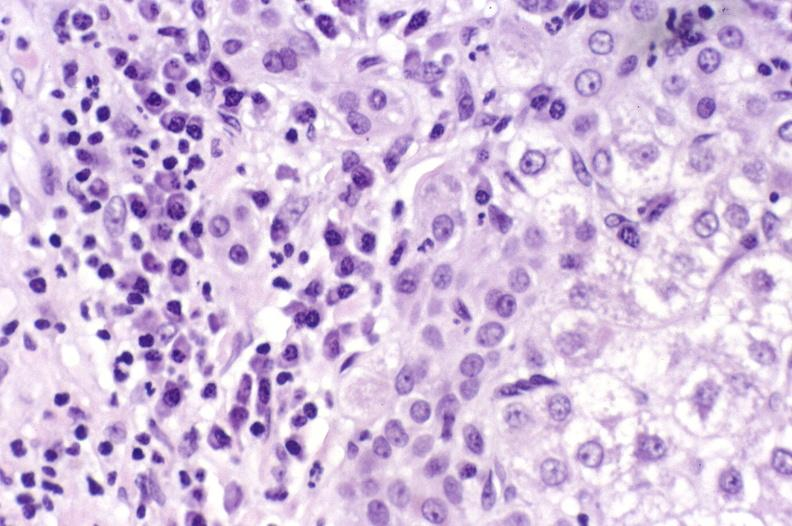does this image show primary biliary cirrhosis?
Answer the question using a single word or phrase. Yes 